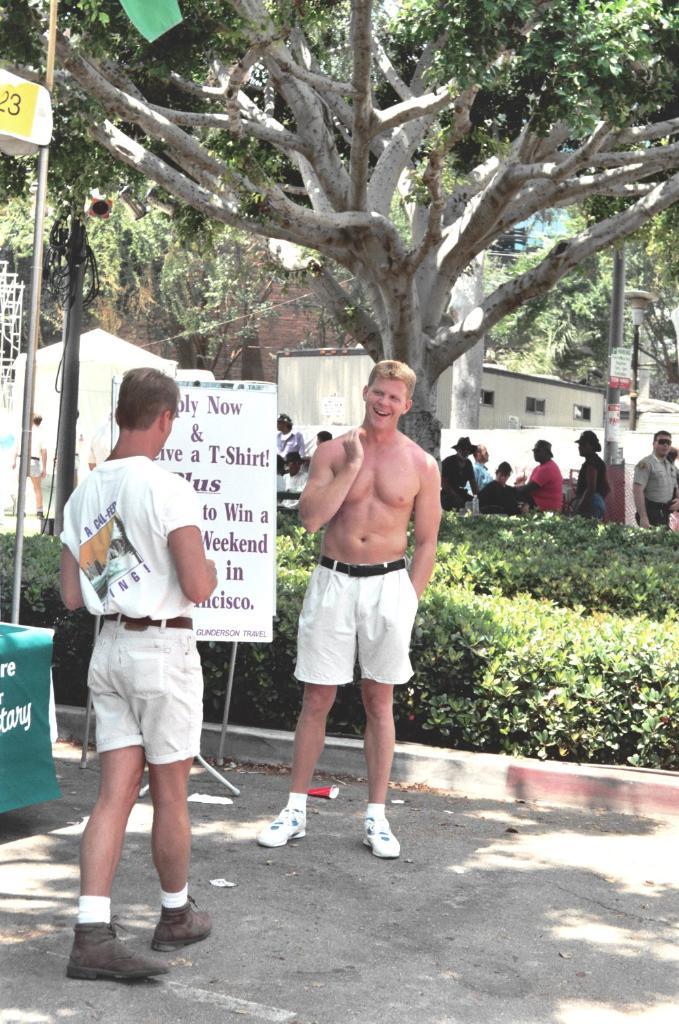What will a person get if they apply now?
Your answer should be very brief. T-shirt. What word is visible on the fifth line of the sign?
Give a very brief answer. Weekend. 